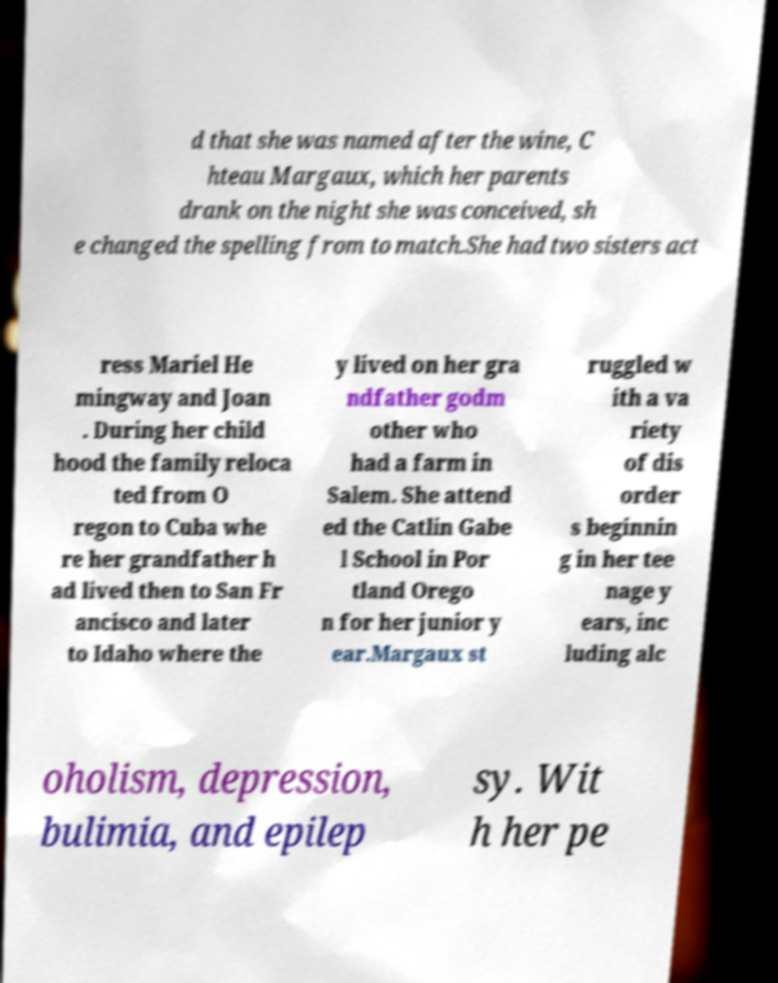I need the written content from this picture converted into text. Can you do that? d that she was named after the wine, C hteau Margaux, which her parents drank on the night she was conceived, sh e changed the spelling from to match.She had two sisters act ress Mariel He mingway and Joan . During her child hood the family reloca ted from O regon to Cuba whe re her grandfather h ad lived then to San Fr ancisco and later to Idaho where the y lived on her gra ndfather godm other who had a farm in Salem. She attend ed the Catlin Gabe l School in Por tland Orego n for her junior y ear.Margaux st ruggled w ith a va riety of dis order s beginnin g in her tee nage y ears, inc luding alc oholism, depression, bulimia, and epilep sy. Wit h her pe 